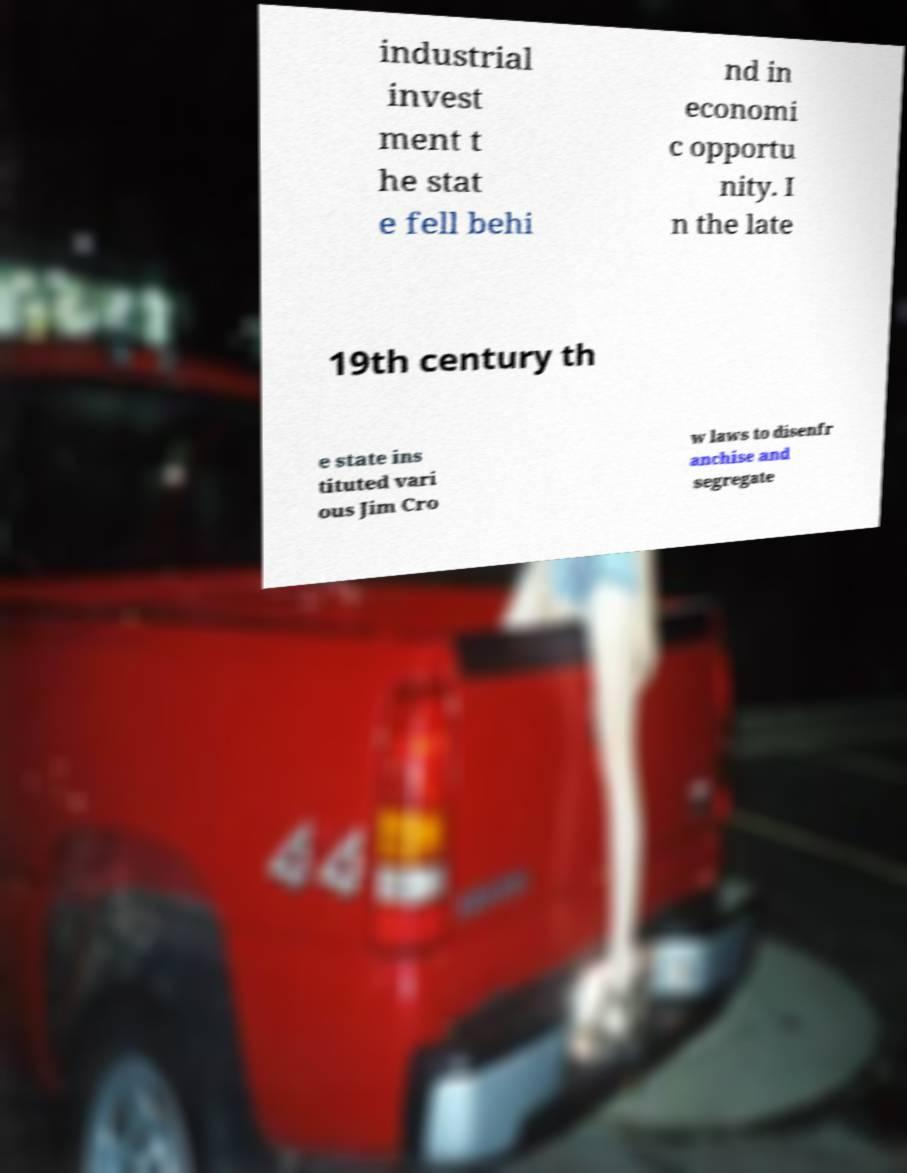I need the written content from this picture converted into text. Can you do that? industrial invest ment t he stat e fell behi nd in economi c opportu nity. I n the late 19th century th e state ins tituted vari ous Jim Cro w laws to disenfr anchise and segregate 